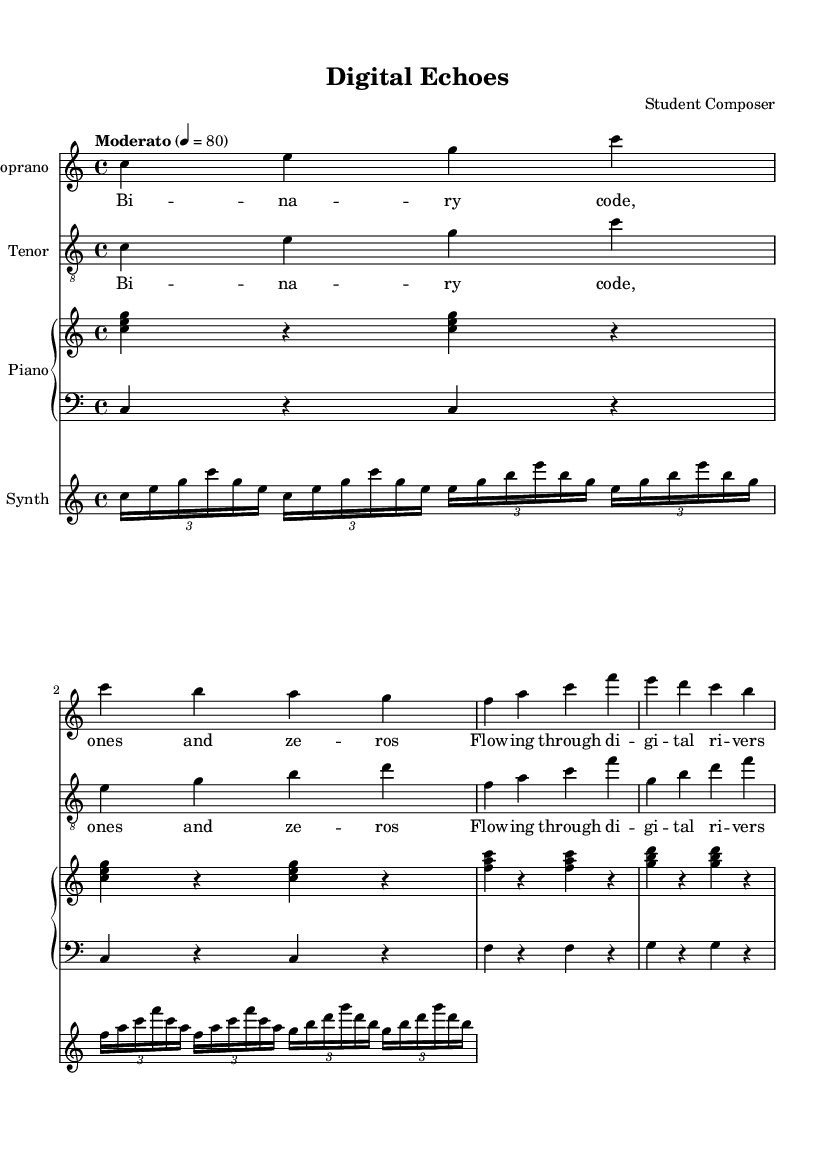What is the key signature of this music? The key signature is indicated at the beginning of the score with no sharps or flats present, which corresponds to C major.
Answer: C major What is the time signature of this music? The time signature is specified at the beginning of the score. It shows a 4 over 4, which indicates that there are four beats in a measure and the quarter note gets one beat.
Answer: 4/4 What is the tempo marking of this piece? The tempo marking is given in the score as "Moderato" with a metronome marking of 80, meaning a moderate speed of 80 beats per minute.
Answer: Moderato, 80 How many verses does the soprano part contain? The soprano part contains two lines of lyrics to their verse, which are repeated in the score. Each line corresponds to a musical phrase that is performed by the soprano.
Answer: 1 verse (repeated) What is the relationship between the lyrics and the tenor part? The lyrics for the tenor part mirror the lyrics of the soprano part exactly, reinforcing the thematic unity of the composition which emphasizes the binary code and digital imagery.
Answer: Same as soprano What instrument is used for the synthesized part? The synthesized part is clearly labeled in the score with the staff indicating it is a "Synth", which suggests electronic sounds are used to complement the traditional vocal lines.
Answer: Synth What is the theme of the chorus lyrics? The chorus lyrics focus on futuristic imagery and silicon technology, which aligns with the technological themes of the opera. This adds to the overarching narrative about the digital age and its resonance in modern life.
Answer: Echoes of the future 